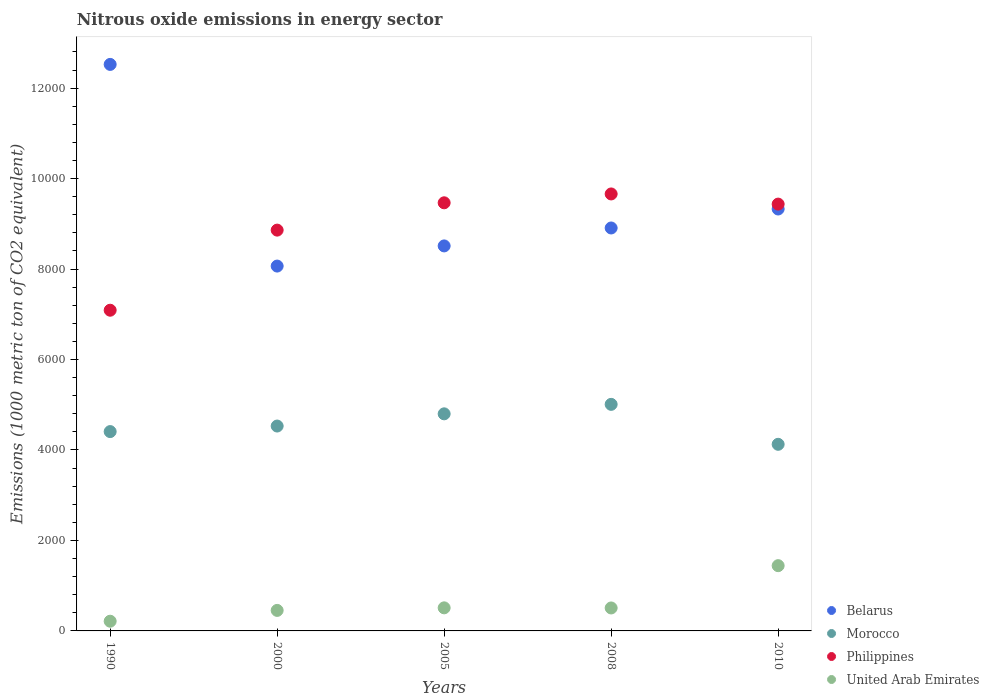Is the number of dotlines equal to the number of legend labels?
Offer a terse response. Yes. What is the amount of nitrous oxide emitted in Belarus in 2005?
Ensure brevity in your answer.  8511.9. Across all years, what is the maximum amount of nitrous oxide emitted in Morocco?
Keep it short and to the point. 5008.9. Across all years, what is the minimum amount of nitrous oxide emitted in United Arab Emirates?
Your answer should be compact. 214.5. In which year was the amount of nitrous oxide emitted in United Arab Emirates maximum?
Ensure brevity in your answer.  2010. In which year was the amount of nitrous oxide emitted in Morocco minimum?
Keep it short and to the point. 2010. What is the total amount of nitrous oxide emitted in Belarus in the graph?
Your response must be concise. 4.73e+04. What is the difference between the amount of nitrous oxide emitted in Belarus in 2000 and that in 2010?
Provide a succinct answer. -1261.7. What is the difference between the amount of nitrous oxide emitted in Morocco in 1990 and the amount of nitrous oxide emitted in Belarus in 2008?
Give a very brief answer. -4501.5. What is the average amount of nitrous oxide emitted in Philippines per year?
Your answer should be very brief. 8902.72. In the year 1990, what is the difference between the amount of nitrous oxide emitted in Morocco and amount of nitrous oxide emitted in Philippines?
Ensure brevity in your answer.  -2683.3. In how many years, is the amount of nitrous oxide emitted in Philippines greater than 2800 1000 metric ton?
Provide a succinct answer. 5. What is the ratio of the amount of nitrous oxide emitted in Morocco in 1990 to that in 2008?
Make the answer very short. 0.88. Is the amount of nitrous oxide emitted in Philippines in 1990 less than that in 2008?
Your response must be concise. Yes. Is the difference between the amount of nitrous oxide emitted in Morocco in 2000 and 2010 greater than the difference between the amount of nitrous oxide emitted in Philippines in 2000 and 2010?
Your response must be concise. Yes. What is the difference between the highest and the second highest amount of nitrous oxide emitted in Morocco?
Your answer should be very brief. 209.5. What is the difference between the highest and the lowest amount of nitrous oxide emitted in Morocco?
Keep it short and to the point. 883.2. Does the amount of nitrous oxide emitted in United Arab Emirates monotonically increase over the years?
Give a very brief answer. No. Is the amount of nitrous oxide emitted in Philippines strictly less than the amount of nitrous oxide emitted in Morocco over the years?
Offer a terse response. No. How many years are there in the graph?
Give a very brief answer. 5. Are the values on the major ticks of Y-axis written in scientific E-notation?
Provide a succinct answer. No. Where does the legend appear in the graph?
Your response must be concise. Bottom right. How many legend labels are there?
Offer a very short reply. 4. What is the title of the graph?
Offer a terse response. Nitrous oxide emissions in energy sector. What is the label or title of the Y-axis?
Offer a very short reply. Emissions (1000 metric ton of CO2 equivalent). What is the Emissions (1000 metric ton of CO2 equivalent) in Belarus in 1990?
Provide a succinct answer. 1.25e+04. What is the Emissions (1000 metric ton of CO2 equivalent) of Morocco in 1990?
Your answer should be very brief. 4406.9. What is the Emissions (1000 metric ton of CO2 equivalent) in Philippines in 1990?
Your response must be concise. 7090.2. What is the Emissions (1000 metric ton of CO2 equivalent) of United Arab Emirates in 1990?
Give a very brief answer. 214.5. What is the Emissions (1000 metric ton of CO2 equivalent) in Belarus in 2000?
Your response must be concise. 8066.2. What is the Emissions (1000 metric ton of CO2 equivalent) of Morocco in 2000?
Offer a terse response. 4529.5. What is the Emissions (1000 metric ton of CO2 equivalent) of Philippines in 2000?
Provide a short and direct response. 8861.1. What is the Emissions (1000 metric ton of CO2 equivalent) in United Arab Emirates in 2000?
Ensure brevity in your answer.  453.6. What is the Emissions (1000 metric ton of CO2 equivalent) of Belarus in 2005?
Make the answer very short. 8511.9. What is the Emissions (1000 metric ton of CO2 equivalent) in Morocco in 2005?
Your answer should be very brief. 4799.4. What is the Emissions (1000 metric ton of CO2 equivalent) in Philippines in 2005?
Provide a short and direct response. 9465.1. What is the Emissions (1000 metric ton of CO2 equivalent) in United Arab Emirates in 2005?
Your response must be concise. 510.2. What is the Emissions (1000 metric ton of CO2 equivalent) in Belarus in 2008?
Offer a terse response. 8908.4. What is the Emissions (1000 metric ton of CO2 equivalent) of Morocco in 2008?
Your response must be concise. 5008.9. What is the Emissions (1000 metric ton of CO2 equivalent) of Philippines in 2008?
Make the answer very short. 9660.8. What is the Emissions (1000 metric ton of CO2 equivalent) of United Arab Emirates in 2008?
Make the answer very short. 507.7. What is the Emissions (1000 metric ton of CO2 equivalent) of Belarus in 2010?
Give a very brief answer. 9327.9. What is the Emissions (1000 metric ton of CO2 equivalent) in Morocco in 2010?
Make the answer very short. 4125.7. What is the Emissions (1000 metric ton of CO2 equivalent) of Philippines in 2010?
Give a very brief answer. 9436.4. What is the Emissions (1000 metric ton of CO2 equivalent) of United Arab Emirates in 2010?
Offer a very short reply. 1442.7. Across all years, what is the maximum Emissions (1000 metric ton of CO2 equivalent) in Belarus?
Your answer should be very brief. 1.25e+04. Across all years, what is the maximum Emissions (1000 metric ton of CO2 equivalent) in Morocco?
Offer a terse response. 5008.9. Across all years, what is the maximum Emissions (1000 metric ton of CO2 equivalent) of Philippines?
Your answer should be compact. 9660.8. Across all years, what is the maximum Emissions (1000 metric ton of CO2 equivalent) of United Arab Emirates?
Ensure brevity in your answer.  1442.7. Across all years, what is the minimum Emissions (1000 metric ton of CO2 equivalent) of Belarus?
Give a very brief answer. 8066.2. Across all years, what is the minimum Emissions (1000 metric ton of CO2 equivalent) in Morocco?
Your answer should be compact. 4125.7. Across all years, what is the minimum Emissions (1000 metric ton of CO2 equivalent) in Philippines?
Make the answer very short. 7090.2. Across all years, what is the minimum Emissions (1000 metric ton of CO2 equivalent) in United Arab Emirates?
Your answer should be very brief. 214.5. What is the total Emissions (1000 metric ton of CO2 equivalent) of Belarus in the graph?
Provide a succinct answer. 4.73e+04. What is the total Emissions (1000 metric ton of CO2 equivalent) in Morocco in the graph?
Offer a very short reply. 2.29e+04. What is the total Emissions (1000 metric ton of CO2 equivalent) in Philippines in the graph?
Keep it short and to the point. 4.45e+04. What is the total Emissions (1000 metric ton of CO2 equivalent) in United Arab Emirates in the graph?
Your answer should be very brief. 3128.7. What is the difference between the Emissions (1000 metric ton of CO2 equivalent) in Belarus in 1990 and that in 2000?
Your response must be concise. 4458.4. What is the difference between the Emissions (1000 metric ton of CO2 equivalent) in Morocco in 1990 and that in 2000?
Provide a succinct answer. -122.6. What is the difference between the Emissions (1000 metric ton of CO2 equivalent) of Philippines in 1990 and that in 2000?
Your answer should be compact. -1770.9. What is the difference between the Emissions (1000 metric ton of CO2 equivalent) in United Arab Emirates in 1990 and that in 2000?
Give a very brief answer. -239.1. What is the difference between the Emissions (1000 metric ton of CO2 equivalent) of Belarus in 1990 and that in 2005?
Provide a short and direct response. 4012.7. What is the difference between the Emissions (1000 metric ton of CO2 equivalent) in Morocco in 1990 and that in 2005?
Your answer should be very brief. -392.5. What is the difference between the Emissions (1000 metric ton of CO2 equivalent) of Philippines in 1990 and that in 2005?
Your answer should be compact. -2374.9. What is the difference between the Emissions (1000 metric ton of CO2 equivalent) in United Arab Emirates in 1990 and that in 2005?
Offer a terse response. -295.7. What is the difference between the Emissions (1000 metric ton of CO2 equivalent) in Belarus in 1990 and that in 2008?
Offer a terse response. 3616.2. What is the difference between the Emissions (1000 metric ton of CO2 equivalent) of Morocco in 1990 and that in 2008?
Offer a terse response. -602. What is the difference between the Emissions (1000 metric ton of CO2 equivalent) of Philippines in 1990 and that in 2008?
Keep it short and to the point. -2570.6. What is the difference between the Emissions (1000 metric ton of CO2 equivalent) in United Arab Emirates in 1990 and that in 2008?
Your answer should be compact. -293.2. What is the difference between the Emissions (1000 metric ton of CO2 equivalent) of Belarus in 1990 and that in 2010?
Your answer should be compact. 3196.7. What is the difference between the Emissions (1000 metric ton of CO2 equivalent) in Morocco in 1990 and that in 2010?
Keep it short and to the point. 281.2. What is the difference between the Emissions (1000 metric ton of CO2 equivalent) of Philippines in 1990 and that in 2010?
Provide a succinct answer. -2346.2. What is the difference between the Emissions (1000 metric ton of CO2 equivalent) of United Arab Emirates in 1990 and that in 2010?
Your answer should be very brief. -1228.2. What is the difference between the Emissions (1000 metric ton of CO2 equivalent) in Belarus in 2000 and that in 2005?
Ensure brevity in your answer.  -445.7. What is the difference between the Emissions (1000 metric ton of CO2 equivalent) in Morocco in 2000 and that in 2005?
Your response must be concise. -269.9. What is the difference between the Emissions (1000 metric ton of CO2 equivalent) in Philippines in 2000 and that in 2005?
Offer a very short reply. -604. What is the difference between the Emissions (1000 metric ton of CO2 equivalent) in United Arab Emirates in 2000 and that in 2005?
Offer a very short reply. -56.6. What is the difference between the Emissions (1000 metric ton of CO2 equivalent) in Belarus in 2000 and that in 2008?
Provide a succinct answer. -842.2. What is the difference between the Emissions (1000 metric ton of CO2 equivalent) in Morocco in 2000 and that in 2008?
Ensure brevity in your answer.  -479.4. What is the difference between the Emissions (1000 metric ton of CO2 equivalent) of Philippines in 2000 and that in 2008?
Offer a very short reply. -799.7. What is the difference between the Emissions (1000 metric ton of CO2 equivalent) in United Arab Emirates in 2000 and that in 2008?
Provide a short and direct response. -54.1. What is the difference between the Emissions (1000 metric ton of CO2 equivalent) in Belarus in 2000 and that in 2010?
Your response must be concise. -1261.7. What is the difference between the Emissions (1000 metric ton of CO2 equivalent) of Morocco in 2000 and that in 2010?
Offer a very short reply. 403.8. What is the difference between the Emissions (1000 metric ton of CO2 equivalent) in Philippines in 2000 and that in 2010?
Give a very brief answer. -575.3. What is the difference between the Emissions (1000 metric ton of CO2 equivalent) in United Arab Emirates in 2000 and that in 2010?
Ensure brevity in your answer.  -989.1. What is the difference between the Emissions (1000 metric ton of CO2 equivalent) of Belarus in 2005 and that in 2008?
Give a very brief answer. -396.5. What is the difference between the Emissions (1000 metric ton of CO2 equivalent) in Morocco in 2005 and that in 2008?
Provide a short and direct response. -209.5. What is the difference between the Emissions (1000 metric ton of CO2 equivalent) of Philippines in 2005 and that in 2008?
Ensure brevity in your answer.  -195.7. What is the difference between the Emissions (1000 metric ton of CO2 equivalent) in Belarus in 2005 and that in 2010?
Offer a very short reply. -816. What is the difference between the Emissions (1000 metric ton of CO2 equivalent) in Morocco in 2005 and that in 2010?
Keep it short and to the point. 673.7. What is the difference between the Emissions (1000 metric ton of CO2 equivalent) of Philippines in 2005 and that in 2010?
Make the answer very short. 28.7. What is the difference between the Emissions (1000 metric ton of CO2 equivalent) in United Arab Emirates in 2005 and that in 2010?
Give a very brief answer. -932.5. What is the difference between the Emissions (1000 metric ton of CO2 equivalent) of Belarus in 2008 and that in 2010?
Your answer should be very brief. -419.5. What is the difference between the Emissions (1000 metric ton of CO2 equivalent) in Morocco in 2008 and that in 2010?
Your answer should be compact. 883.2. What is the difference between the Emissions (1000 metric ton of CO2 equivalent) of Philippines in 2008 and that in 2010?
Offer a very short reply. 224.4. What is the difference between the Emissions (1000 metric ton of CO2 equivalent) of United Arab Emirates in 2008 and that in 2010?
Provide a short and direct response. -935. What is the difference between the Emissions (1000 metric ton of CO2 equivalent) of Belarus in 1990 and the Emissions (1000 metric ton of CO2 equivalent) of Morocco in 2000?
Your response must be concise. 7995.1. What is the difference between the Emissions (1000 metric ton of CO2 equivalent) of Belarus in 1990 and the Emissions (1000 metric ton of CO2 equivalent) of Philippines in 2000?
Give a very brief answer. 3663.5. What is the difference between the Emissions (1000 metric ton of CO2 equivalent) in Belarus in 1990 and the Emissions (1000 metric ton of CO2 equivalent) in United Arab Emirates in 2000?
Provide a short and direct response. 1.21e+04. What is the difference between the Emissions (1000 metric ton of CO2 equivalent) of Morocco in 1990 and the Emissions (1000 metric ton of CO2 equivalent) of Philippines in 2000?
Offer a terse response. -4454.2. What is the difference between the Emissions (1000 metric ton of CO2 equivalent) in Morocco in 1990 and the Emissions (1000 metric ton of CO2 equivalent) in United Arab Emirates in 2000?
Keep it short and to the point. 3953.3. What is the difference between the Emissions (1000 metric ton of CO2 equivalent) of Philippines in 1990 and the Emissions (1000 metric ton of CO2 equivalent) of United Arab Emirates in 2000?
Provide a succinct answer. 6636.6. What is the difference between the Emissions (1000 metric ton of CO2 equivalent) in Belarus in 1990 and the Emissions (1000 metric ton of CO2 equivalent) in Morocco in 2005?
Your answer should be compact. 7725.2. What is the difference between the Emissions (1000 metric ton of CO2 equivalent) in Belarus in 1990 and the Emissions (1000 metric ton of CO2 equivalent) in Philippines in 2005?
Provide a short and direct response. 3059.5. What is the difference between the Emissions (1000 metric ton of CO2 equivalent) of Belarus in 1990 and the Emissions (1000 metric ton of CO2 equivalent) of United Arab Emirates in 2005?
Ensure brevity in your answer.  1.20e+04. What is the difference between the Emissions (1000 metric ton of CO2 equivalent) in Morocco in 1990 and the Emissions (1000 metric ton of CO2 equivalent) in Philippines in 2005?
Your response must be concise. -5058.2. What is the difference between the Emissions (1000 metric ton of CO2 equivalent) of Morocco in 1990 and the Emissions (1000 metric ton of CO2 equivalent) of United Arab Emirates in 2005?
Offer a very short reply. 3896.7. What is the difference between the Emissions (1000 metric ton of CO2 equivalent) of Philippines in 1990 and the Emissions (1000 metric ton of CO2 equivalent) of United Arab Emirates in 2005?
Keep it short and to the point. 6580. What is the difference between the Emissions (1000 metric ton of CO2 equivalent) of Belarus in 1990 and the Emissions (1000 metric ton of CO2 equivalent) of Morocco in 2008?
Your response must be concise. 7515.7. What is the difference between the Emissions (1000 metric ton of CO2 equivalent) of Belarus in 1990 and the Emissions (1000 metric ton of CO2 equivalent) of Philippines in 2008?
Offer a very short reply. 2863.8. What is the difference between the Emissions (1000 metric ton of CO2 equivalent) in Belarus in 1990 and the Emissions (1000 metric ton of CO2 equivalent) in United Arab Emirates in 2008?
Offer a terse response. 1.20e+04. What is the difference between the Emissions (1000 metric ton of CO2 equivalent) in Morocco in 1990 and the Emissions (1000 metric ton of CO2 equivalent) in Philippines in 2008?
Offer a very short reply. -5253.9. What is the difference between the Emissions (1000 metric ton of CO2 equivalent) in Morocco in 1990 and the Emissions (1000 metric ton of CO2 equivalent) in United Arab Emirates in 2008?
Provide a succinct answer. 3899.2. What is the difference between the Emissions (1000 metric ton of CO2 equivalent) of Philippines in 1990 and the Emissions (1000 metric ton of CO2 equivalent) of United Arab Emirates in 2008?
Provide a short and direct response. 6582.5. What is the difference between the Emissions (1000 metric ton of CO2 equivalent) in Belarus in 1990 and the Emissions (1000 metric ton of CO2 equivalent) in Morocco in 2010?
Make the answer very short. 8398.9. What is the difference between the Emissions (1000 metric ton of CO2 equivalent) in Belarus in 1990 and the Emissions (1000 metric ton of CO2 equivalent) in Philippines in 2010?
Offer a terse response. 3088.2. What is the difference between the Emissions (1000 metric ton of CO2 equivalent) in Belarus in 1990 and the Emissions (1000 metric ton of CO2 equivalent) in United Arab Emirates in 2010?
Offer a very short reply. 1.11e+04. What is the difference between the Emissions (1000 metric ton of CO2 equivalent) of Morocco in 1990 and the Emissions (1000 metric ton of CO2 equivalent) of Philippines in 2010?
Provide a short and direct response. -5029.5. What is the difference between the Emissions (1000 metric ton of CO2 equivalent) in Morocco in 1990 and the Emissions (1000 metric ton of CO2 equivalent) in United Arab Emirates in 2010?
Your answer should be very brief. 2964.2. What is the difference between the Emissions (1000 metric ton of CO2 equivalent) in Philippines in 1990 and the Emissions (1000 metric ton of CO2 equivalent) in United Arab Emirates in 2010?
Keep it short and to the point. 5647.5. What is the difference between the Emissions (1000 metric ton of CO2 equivalent) of Belarus in 2000 and the Emissions (1000 metric ton of CO2 equivalent) of Morocco in 2005?
Keep it short and to the point. 3266.8. What is the difference between the Emissions (1000 metric ton of CO2 equivalent) of Belarus in 2000 and the Emissions (1000 metric ton of CO2 equivalent) of Philippines in 2005?
Provide a succinct answer. -1398.9. What is the difference between the Emissions (1000 metric ton of CO2 equivalent) of Belarus in 2000 and the Emissions (1000 metric ton of CO2 equivalent) of United Arab Emirates in 2005?
Make the answer very short. 7556. What is the difference between the Emissions (1000 metric ton of CO2 equivalent) in Morocco in 2000 and the Emissions (1000 metric ton of CO2 equivalent) in Philippines in 2005?
Make the answer very short. -4935.6. What is the difference between the Emissions (1000 metric ton of CO2 equivalent) of Morocco in 2000 and the Emissions (1000 metric ton of CO2 equivalent) of United Arab Emirates in 2005?
Make the answer very short. 4019.3. What is the difference between the Emissions (1000 metric ton of CO2 equivalent) of Philippines in 2000 and the Emissions (1000 metric ton of CO2 equivalent) of United Arab Emirates in 2005?
Your answer should be very brief. 8350.9. What is the difference between the Emissions (1000 metric ton of CO2 equivalent) in Belarus in 2000 and the Emissions (1000 metric ton of CO2 equivalent) in Morocco in 2008?
Keep it short and to the point. 3057.3. What is the difference between the Emissions (1000 metric ton of CO2 equivalent) of Belarus in 2000 and the Emissions (1000 metric ton of CO2 equivalent) of Philippines in 2008?
Give a very brief answer. -1594.6. What is the difference between the Emissions (1000 metric ton of CO2 equivalent) of Belarus in 2000 and the Emissions (1000 metric ton of CO2 equivalent) of United Arab Emirates in 2008?
Give a very brief answer. 7558.5. What is the difference between the Emissions (1000 metric ton of CO2 equivalent) in Morocco in 2000 and the Emissions (1000 metric ton of CO2 equivalent) in Philippines in 2008?
Provide a succinct answer. -5131.3. What is the difference between the Emissions (1000 metric ton of CO2 equivalent) in Morocco in 2000 and the Emissions (1000 metric ton of CO2 equivalent) in United Arab Emirates in 2008?
Make the answer very short. 4021.8. What is the difference between the Emissions (1000 metric ton of CO2 equivalent) of Philippines in 2000 and the Emissions (1000 metric ton of CO2 equivalent) of United Arab Emirates in 2008?
Your response must be concise. 8353.4. What is the difference between the Emissions (1000 metric ton of CO2 equivalent) in Belarus in 2000 and the Emissions (1000 metric ton of CO2 equivalent) in Morocco in 2010?
Provide a succinct answer. 3940.5. What is the difference between the Emissions (1000 metric ton of CO2 equivalent) of Belarus in 2000 and the Emissions (1000 metric ton of CO2 equivalent) of Philippines in 2010?
Offer a very short reply. -1370.2. What is the difference between the Emissions (1000 metric ton of CO2 equivalent) in Belarus in 2000 and the Emissions (1000 metric ton of CO2 equivalent) in United Arab Emirates in 2010?
Your answer should be compact. 6623.5. What is the difference between the Emissions (1000 metric ton of CO2 equivalent) of Morocco in 2000 and the Emissions (1000 metric ton of CO2 equivalent) of Philippines in 2010?
Your answer should be very brief. -4906.9. What is the difference between the Emissions (1000 metric ton of CO2 equivalent) in Morocco in 2000 and the Emissions (1000 metric ton of CO2 equivalent) in United Arab Emirates in 2010?
Give a very brief answer. 3086.8. What is the difference between the Emissions (1000 metric ton of CO2 equivalent) of Philippines in 2000 and the Emissions (1000 metric ton of CO2 equivalent) of United Arab Emirates in 2010?
Provide a succinct answer. 7418.4. What is the difference between the Emissions (1000 metric ton of CO2 equivalent) in Belarus in 2005 and the Emissions (1000 metric ton of CO2 equivalent) in Morocco in 2008?
Give a very brief answer. 3503. What is the difference between the Emissions (1000 metric ton of CO2 equivalent) in Belarus in 2005 and the Emissions (1000 metric ton of CO2 equivalent) in Philippines in 2008?
Offer a very short reply. -1148.9. What is the difference between the Emissions (1000 metric ton of CO2 equivalent) in Belarus in 2005 and the Emissions (1000 metric ton of CO2 equivalent) in United Arab Emirates in 2008?
Your response must be concise. 8004.2. What is the difference between the Emissions (1000 metric ton of CO2 equivalent) of Morocco in 2005 and the Emissions (1000 metric ton of CO2 equivalent) of Philippines in 2008?
Your response must be concise. -4861.4. What is the difference between the Emissions (1000 metric ton of CO2 equivalent) in Morocco in 2005 and the Emissions (1000 metric ton of CO2 equivalent) in United Arab Emirates in 2008?
Give a very brief answer. 4291.7. What is the difference between the Emissions (1000 metric ton of CO2 equivalent) of Philippines in 2005 and the Emissions (1000 metric ton of CO2 equivalent) of United Arab Emirates in 2008?
Your response must be concise. 8957.4. What is the difference between the Emissions (1000 metric ton of CO2 equivalent) in Belarus in 2005 and the Emissions (1000 metric ton of CO2 equivalent) in Morocco in 2010?
Your answer should be very brief. 4386.2. What is the difference between the Emissions (1000 metric ton of CO2 equivalent) in Belarus in 2005 and the Emissions (1000 metric ton of CO2 equivalent) in Philippines in 2010?
Keep it short and to the point. -924.5. What is the difference between the Emissions (1000 metric ton of CO2 equivalent) in Belarus in 2005 and the Emissions (1000 metric ton of CO2 equivalent) in United Arab Emirates in 2010?
Offer a very short reply. 7069.2. What is the difference between the Emissions (1000 metric ton of CO2 equivalent) of Morocco in 2005 and the Emissions (1000 metric ton of CO2 equivalent) of Philippines in 2010?
Provide a succinct answer. -4637. What is the difference between the Emissions (1000 metric ton of CO2 equivalent) in Morocco in 2005 and the Emissions (1000 metric ton of CO2 equivalent) in United Arab Emirates in 2010?
Provide a short and direct response. 3356.7. What is the difference between the Emissions (1000 metric ton of CO2 equivalent) of Philippines in 2005 and the Emissions (1000 metric ton of CO2 equivalent) of United Arab Emirates in 2010?
Your response must be concise. 8022.4. What is the difference between the Emissions (1000 metric ton of CO2 equivalent) of Belarus in 2008 and the Emissions (1000 metric ton of CO2 equivalent) of Morocco in 2010?
Your answer should be very brief. 4782.7. What is the difference between the Emissions (1000 metric ton of CO2 equivalent) in Belarus in 2008 and the Emissions (1000 metric ton of CO2 equivalent) in Philippines in 2010?
Your response must be concise. -528. What is the difference between the Emissions (1000 metric ton of CO2 equivalent) in Belarus in 2008 and the Emissions (1000 metric ton of CO2 equivalent) in United Arab Emirates in 2010?
Keep it short and to the point. 7465.7. What is the difference between the Emissions (1000 metric ton of CO2 equivalent) of Morocco in 2008 and the Emissions (1000 metric ton of CO2 equivalent) of Philippines in 2010?
Make the answer very short. -4427.5. What is the difference between the Emissions (1000 metric ton of CO2 equivalent) in Morocco in 2008 and the Emissions (1000 metric ton of CO2 equivalent) in United Arab Emirates in 2010?
Provide a succinct answer. 3566.2. What is the difference between the Emissions (1000 metric ton of CO2 equivalent) of Philippines in 2008 and the Emissions (1000 metric ton of CO2 equivalent) of United Arab Emirates in 2010?
Your answer should be compact. 8218.1. What is the average Emissions (1000 metric ton of CO2 equivalent) of Belarus per year?
Offer a very short reply. 9467.8. What is the average Emissions (1000 metric ton of CO2 equivalent) of Morocco per year?
Your answer should be very brief. 4574.08. What is the average Emissions (1000 metric ton of CO2 equivalent) in Philippines per year?
Give a very brief answer. 8902.72. What is the average Emissions (1000 metric ton of CO2 equivalent) of United Arab Emirates per year?
Keep it short and to the point. 625.74. In the year 1990, what is the difference between the Emissions (1000 metric ton of CO2 equivalent) of Belarus and Emissions (1000 metric ton of CO2 equivalent) of Morocco?
Keep it short and to the point. 8117.7. In the year 1990, what is the difference between the Emissions (1000 metric ton of CO2 equivalent) in Belarus and Emissions (1000 metric ton of CO2 equivalent) in Philippines?
Your response must be concise. 5434.4. In the year 1990, what is the difference between the Emissions (1000 metric ton of CO2 equivalent) of Belarus and Emissions (1000 metric ton of CO2 equivalent) of United Arab Emirates?
Make the answer very short. 1.23e+04. In the year 1990, what is the difference between the Emissions (1000 metric ton of CO2 equivalent) of Morocco and Emissions (1000 metric ton of CO2 equivalent) of Philippines?
Offer a very short reply. -2683.3. In the year 1990, what is the difference between the Emissions (1000 metric ton of CO2 equivalent) in Morocco and Emissions (1000 metric ton of CO2 equivalent) in United Arab Emirates?
Your answer should be very brief. 4192.4. In the year 1990, what is the difference between the Emissions (1000 metric ton of CO2 equivalent) of Philippines and Emissions (1000 metric ton of CO2 equivalent) of United Arab Emirates?
Offer a very short reply. 6875.7. In the year 2000, what is the difference between the Emissions (1000 metric ton of CO2 equivalent) of Belarus and Emissions (1000 metric ton of CO2 equivalent) of Morocco?
Your answer should be very brief. 3536.7. In the year 2000, what is the difference between the Emissions (1000 metric ton of CO2 equivalent) of Belarus and Emissions (1000 metric ton of CO2 equivalent) of Philippines?
Keep it short and to the point. -794.9. In the year 2000, what is the difference between the Emissions (1000 metric ton of CO2 equivalent) in Belarus and Emissions (1000 metric ton of CO2 equivalent) in United Arab Emirates?
Keep it short and to the point. 7612.6. In the year 2000, what is the difference between the Emissions (1000 metric ton of CO2 equivalent) of Morocco and Emissions (1000 metric ton of CO2 equivalent) of Philippines?
Provide a succinct answer. -4331.6. In the year 2000, what is the difference between the Emissions (1000 metric ton of CO2 equivalent) of Morocco and Emissions (1000 metric ton of CO2 equivalent) of United Arab Emirates?
Give a very brief answer. 4075.9. In the year 2000, what is the difference between the Emissions (1000 metric ton of CO2 equivalent) in Philippines and Emissions (1000 metric ton of CO2 equivalent) in United Arab Emirates?
Make the answer very short. 8407.5. In the year 2005, what is the difference between the Emissions (1000 metric ton of CO2 equivalent) in Belarus and Emissions (1000 metric ton of CO2 equivalent) in Morocco?
Keep it short and to the point. 3712.5. In the year 2005, what is the difference between the Emissions (1000 metric ton of CO2 equivalent) of Belarus and Emissions (1000 metric ton of CO2 equivalent) of Philippines?
Provide a short and direct response. -953.2. In the year 2005, what is the difference between the Emissions (1000 metric ton of CO2 equivalent) of Belarus and Emissions (1000 metric ton of CO2 equivalent) of United Arab Emirates?
Your response must be concise. 8001.7. In the year 2005, what is the difference between the Emissions (1000 metric ton of CO2 equivalent) of Morocco and Emissions (1000 metric ton of CO2 equivalent) of Philippines?
Offer a very short reply. -4665.7. In the year 2005, what is the difference between the Emissions (1000 metric ton of CO2 equivalent) of Morocco and Emissions (1000 metric ton of CO2 equivalent) of United Arab Emirates?
Your answer should be compact. 4289.2. In the year 2005, what is the difference between the Emissions (1000 metric ton of CO2 equivalent) in Philippines and Emissions (1000 metric ton of CO2 equivalent) in United Arab Emirates?
Your answer should be compact. 8954.9. In the year 2008, what is the difference between the Emissions (1000 metric ton of CO2 equivalent) in Belarus and Emissions (1000 metric ton of CO2 equivalent) in Morocco?
Keep it short and to the point. 3899.5. In the year 2008, what is the difference between the Emissions (1000 metric ton of CO2 equivalent) of Belarus and Emissions (1000 metric ton of CO2 equivalent) of Philippines?
Your answer should be compact. -752.4. In the year 2008, what is the difference between the Emissions (1000 metric ton of CO2 equivalent) in Belarus and Emissions (1000 metric ton of CO2 equivalent) in United Arab Emirates?
Keep it short and to the point. 8400.7. In the year 2008, what is the difference between the Emissions (1000 metric ton of CO2 equivalent) in Morocco and Emissions (1000 metric ton of CO2 equivalent) in Philippines?
Your answer should be compact. -4651.9. In the year 2008, what is the difference between the Emissions (1000 metric ton of CO2 equivalent) in Morocco and Emissions (1000 metric ton of CO2 equivalent) in United Arab Emirates?
Offer a terse response. 4501.2. In the year 2008, what is the difference between the Emissions (1000 metric ton of CO2 equivalent) of Philippines and Emissions (1000 metric ton of CO2 equivalent) of United Arab Emirates?
Offer a terse response. 9153.1. In the year 2010, what is the difference between the Emissions (1000 metric ton of CO2 equivalent) of Belarus and Emissions (1000 metric ton of CO2 equivalent) of Morocco?
Keep it short and to the point. 5202.2. In the year 2010, what is the difference between the Emissions (1000 metric ton of CO2 equivalent) of Belarus and Emissions (1000 metric ton of CO2 equivalent) of Philippines?
Keep it short and to the point. -108.5. In the year 2010, what is the difference between the Emissions (1000 metric ton of CO2 equivalent) of Belarus and Emissions (1000 metric ton of CO2 equivalent) of United Arab Emirates?
Your answer should be very brief. 7885.2. In the year 2010, what is the difference between the Emissions (1000 metric ton of CO2 equivalent) of Morocco and Emissions (1000 metric ton of CO2 equivalent) of Philippines?
Keep it short and to the point. -5310.7. In the year 2010, what is the difference between the Emissions (1000 metric ton of CO2 equivalent) in Morocco and Emissions (1000 metric ton of CO2 equivalent) in United Arab Emirates?
Give a very brief answer. 2683. In the year 2010, what is the difference between the Emissions (1000 metric ton of CO2 equivalent) of Philippines and Emissions (1000 metric ton of CO2 equivalent) of United Arab Emirates?
Your answer should be very brief. 7993.7. What is the ratio of the Emissions (1000 metric ton of CO2 equivalent) of Belarus in 1990 to that in 2000?
Offer a very short reply. 1.55. What is the ratio of the Emissions (1000 metric ton of CO2 equivalent) of Morocco in 1990 to that in 2000?
Give a very brief answer. 0.97. What is the ratio of the Emissions (1000 metric ton of CO2 equivalent) of Philippines in 1990 to that in 2000?
Keep it short and to the point. 0.8. What is the ratio of the Emissions (1000 metric ton of CO2 equivalent) in United Arab Emirates in 1990 to that in 2000?
Your answer should be very brief. 0.47. What is the ratio of the Emissions (1000 metric ton of CO2 equivalent) in Belarus in 1990 to that in 2005?
Keep it short and to the point. 1.47. What is the ratio of the Emissions (1000 metric ton of CO2 equivalent) of Morocco in 1990 to that in 2005?
Ensure brevity in your answer.  0.92. What is the ratio of the Emissions (1000 metric ton of CO2 equivalent) in Philippines in 1990 to that in 2005?
Ensure brevity in your answer.  0.75. What is the ratio of the Emissions (1000 metric ton of CO2 equivalent) in United Arab Emirates in 1990 to that in 2005?
Your response must be concise. 0.42. What is the ratio of the Emissions (1000 metric ton of CO2 equivalent) in Belarus in 1990 to that in 2008?
Your answer should be compact. 1.41. What is the ratio of the Emissions (1000 metric ton of CO2 equivalent) in Morocco in 1990 to that in 2008?
Ensure brevity in your answer.  0.88. What is the ratio of the Emissions (1000 metric ton of CO2 equivalent) in Philippines in 1990 to that in 2008?
Your answer should be very brief. 0.73. What is the ratio of the Emissions (1000 metric ton of CO2 equivalent) in United Arab Emirates in 1990 to that in 2008?
Provide a succinct answer. 0.42. What is the ratio of the Emissions (1000 metric ton of CO2 equivalent) in Belarus in 1990 to that in 2010?
Make the answer very short. 1.34. What is the ratio of the Emissions (1000 metric ton of CO2 equivalent) in Morocco in 1990 to that in 2010?
Make the answer very short. 1.07. What is the ratio of the Emissions (1000 metric ton of CO2 equivalent) of Philippines in 1990 to that in 2010?
Your response must be concise. 0.75. What is the ratio of the Emissions (1000 metric ton of CO2 equivalent) of United Arab Emirates in 1990 to that in 2010?
Ensure brevity in your answer.  0.15. What is the ratio of the Emissions (1000 metric ton of CO2 equivalent) in Belarus in 2000 to that in 2005?
Your answer should be very brief. 0.95. What is the ratio of the Emissions (1000 metric ton of CO2 equivalent) in Morocco in 2000 to that in 2005?
Ensure brevity in your answer.  0.94. What is the ratio of the Emissions (1000 metric ton of CO2 equivalent) of Philippines in 2000 to that in 2005?
Provide a succinct answer. 0.94. What is the ratio of the Emissions (1000 metric ton of CO2 equivalent) in United Arab Emirates in 2000 to that in 2005?
Offer a terse response. 0.89. What is the ratio of the Emissions (1000 metric ton of CO2 equivalent) in Belarus in 2000 to that in 2008?
Provide a succinct answer. 0.91. What is the ratio of the Emissions (1000 metric ton of CO2 equivalent) of Morocco in 2000 to that in 2008?
Your response must be concise. 0.9. What is the ratio of the Emissions (1000 metric ton of CO2 equivalent) in Philippines in 2000 to that in 2008?
Give a very brief answer. 0.92. What is the ratio of the Emissions (1000 metric ton of CO2 equivalent) of United Arab Emirates in 2000 to that in 2008?
Offer a very short reply. 0.89. What is the ratio of the Emissions (1000 metric ton of CO2 equivalent) of Belarus in 2000 to that in 2010?
Ensure brevity in your answer.  0.86. What is the ratio of the Emissions (1000 metric ton of CO2 equivalent) of Morocco in 2000 to that in 2010?
Keep it short and to the point. 1.1. What is the ratio of the Emissions (1000 metric ton of CO2 equivalent) of Philippines in 2000 to that in 2010?
Your answer should be compact. 0.94. What is the ratio of the Emissions (1000 metric ton of CO2 equivalent) of United Arab Emirates in 2000 to that in 2010?
Offer a very short reply. 0.31. What is the ratio of the Emissions (1000 metric ton of CO2 equivalent) in Belarus in 2005 to that in 2008?
Give a very brief answer. 0.96. What is the ratio of the Emissions (1000 metric ton of CO2 equivalent) of Morocco in 2005 to that in 2008?
Your response must be concise. 0.96. What is the ratio of the Emissions (1000 metric ton of CO2 equivalent) in Philippines in 2005 to that in 2008?
Ensure brevity in your answer.  0.98. What is the ratio of the Emissions (1000 metric ton of CO2 equivalent) in United Arab Emirates in 2005 to that in 2008?
Ensure brevity in your answer.  1. What is the ratio of the Emissions (1000 metric ton of CO2 equivalent) of Belarus in 2005 to that in 2010?
Provide a succinct answer. 0.91. What is the ratio of the Emissions (1000 metric ton of CO2 equivalent) of Morocco in 2005 to that in 2010?
Your response must be concise. 1.16. What is the ratio of the Emissions (1000 metric ton of CO2 equivalent) in Philippines in 2005 to that in 2010?
Give a very brief answer. 1. What is the ratio of the Emissions (1000 metric ton of CO2 equivalent) of United Arab Emirates in 2005 to that in 2010?
Provide a short and direct response. 0.35. What is the ratio of the Emissions (1000 metric ton of CO2 equivalent) in Belarus in 2008 to that in 2010?
Give a very brief answer. 0.95. What is the ratio of the Emissions (1000 metric ton of CO2 equivalent) in Morocco in 2008 to that in 2010?
Offer a very short reply. 1.21. What is the ratio of the Emissions (1000 metric ton of CO2 equivalent) in Philippines in 2008 to that in 2010?
Offer a very short reply. 1.02. What is the ratio of the Emissions (1000 metric ton of CO2 equivalent) of United Arab Emirates in 2008 to that in 2010?
Give a very brief answer. 0.35. What is the difference between the highest and the second highest Emissions (1000 metric ton of CO2 equivalent) in Belarus?
Your answer should be very brief. 3196.7. What is the difference between the highest and the second highest Emissions (1000 metric ton of CO2 equivalent) in Morocco?
Provide a succinct answer. 209.5. What is the difference between the highest and the second highest Emissions (1000 metric ton of CO2 equivalent) of Philippines?
Provide a short and direct response. 195.7. What is the difference between the highest and the second highest Emissions (1000 metric ton of CO2 equivalent) of United Arab Emirates?
Keep it short and to the point. 932.5. What is the difference between the highest and the lowest Emissions (1000 metric ton of CO2 equivalent) in Belarus?
Give a very brief answer. 4458.4. What is the difference between the highest and the lowest Emissions (1000 metric ton of CO2 equivalent) in Morocco?
Offer a very short reply. 883.2. What is the difference between the highest and the lowest Emissions (1000 metric ton of CO2 equivalent) in Philippines?
Give a very brief answer. 2570.6. What is the difference between the highest and the lowest Emissions (1000 metric ton of CO2 equivalent) of United Arab Emirates?
Ensure brevity in your answer.  1228.2. 